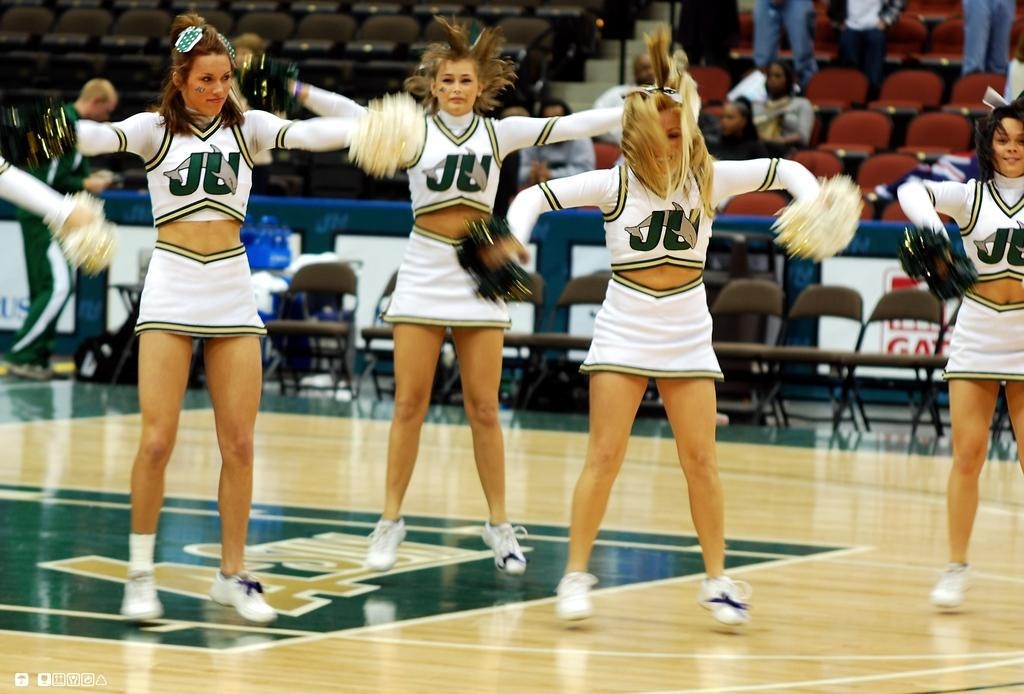<image>
Share a concise interpretation of the image provided. Girls in cheer leading outfits that say JU on the front. 